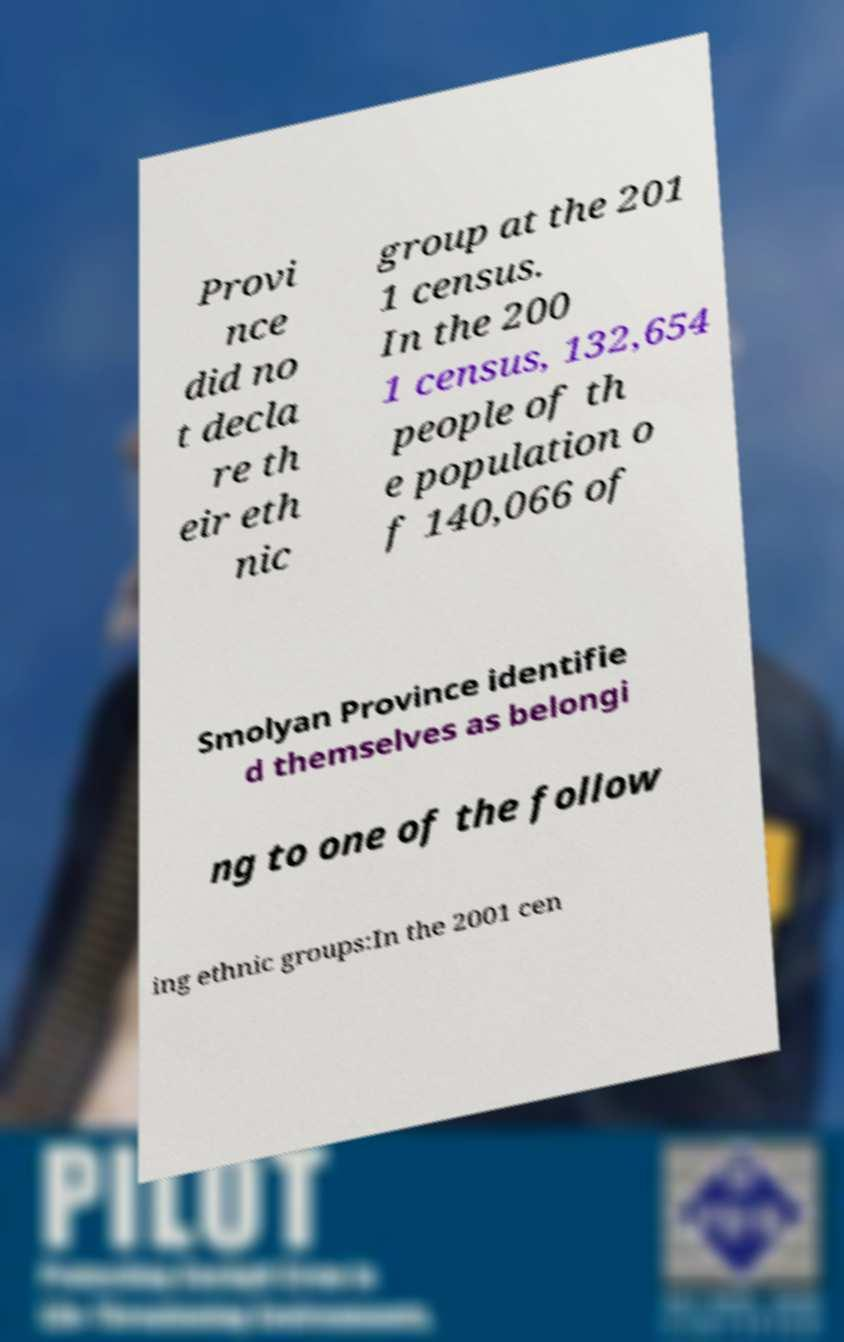I need the written content from this picture converted into text. Can you do that? Provi nce did no t decla re th eir eth nic group at the 201 1 census. In the 200 1 census, 132,654 people of th e population o f 140,066 of Smolyan Province identifie d themselves as belongi ng to one of the follow ing ethnic groups:In the 2001 cen 